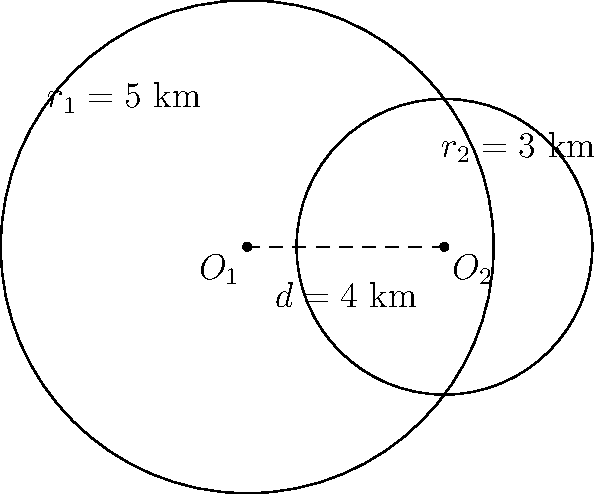Two circular water catchment zones in a mining operation overlap as shown in the diagram. The first zone has a radius of 5 km, and the second has a radius of 3 km. The centers of the circles are 4 km apart. Calculate the area of the overlapping region to determine the extent of shared water resources. Round your answer to the nearest square kilometer. To find the area of overlap between two circles, we'll use the formula for the area of intersection of two circles:

$$A = r_1^2 \arccos\left(\frac{d^2 + r_1^2 - r_2^2}{2dr_1}\right) + r_2^2 \arccos\left(\frac{d^2 + r_2^2 - r_1^2}{2dr_2}\right) - \frac{1}{2}\sqrt{(-d+r_1+r_2)(d+r_1-r_2)(d-r_1+r_2)(d+r_1+r_2)}$$

Where:
$r_1 = 5$ km (radius of the first circle)
$r_2 = 3$ km (radius of the second circle)
$d = 4$ km (distance between circle centers)

Step 1: Calculate the first arccos term:
$$\arccos\left(\frac{4^2 + 5^2 - 3^2}{2 \cdot 4 \cdot 5}\right) = \arccos(0.6875) \approx 0.8029$$

Step 2: Calculate the second arccos term:
$$\arccos\left(\frac{4^2 + 3^2 - 5^2}{2 \cdot 4 \cdot 3}\right) = \arccos(-0.4583) \approx 2.0344$$

Step 3: Calculate the square root term:
$$\sqrt{(-4+5+3)(4+5-3)(4-5+3)(4+5+3)} = \sqrt{4 \cdot 6 \cdot 2 \cdot 12} = \sqrt{576} = 24$$

Step 4: Put it all together:
$$A = 5^2 \cdot 0.8029 + 3^2 \cdot 2.0344 - \frac{1}{2} \cdot 24$$
$$A = 20.0725 + 18.3096 - 12 = 26.3821$$

Step 5: Round to the nearest square kilometer:
$$A \approx 26 \text{ km}^2$$
Answer: 26 km² 